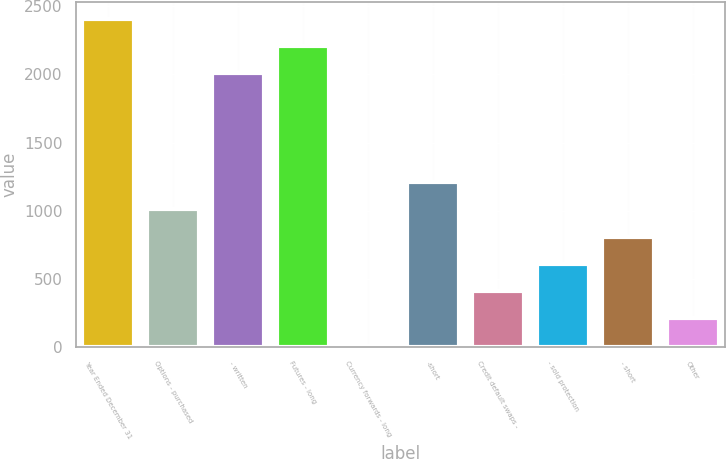Convert chart to OTSL. <chart><loc_0><loc_0><loc_500><loc_500><bar_chart><fcel>Year Ended December 31<fcel>Options - purchased<fcel>- written<fcel>Futures - long<fcel>Currency forwards - long<fcel>-short<fcel>Credit default swaps -<fcel>- sold protection<fcel>- short<fcel>Other<nl><fcel>2407.4<fcel>1009.5<fcel>2008<fcel>2207.7<fcel>11<fcel>1209.2<fcel>410.4<fcel>610.1<fcel>809.8<fcel>210.7<nl></chart> 